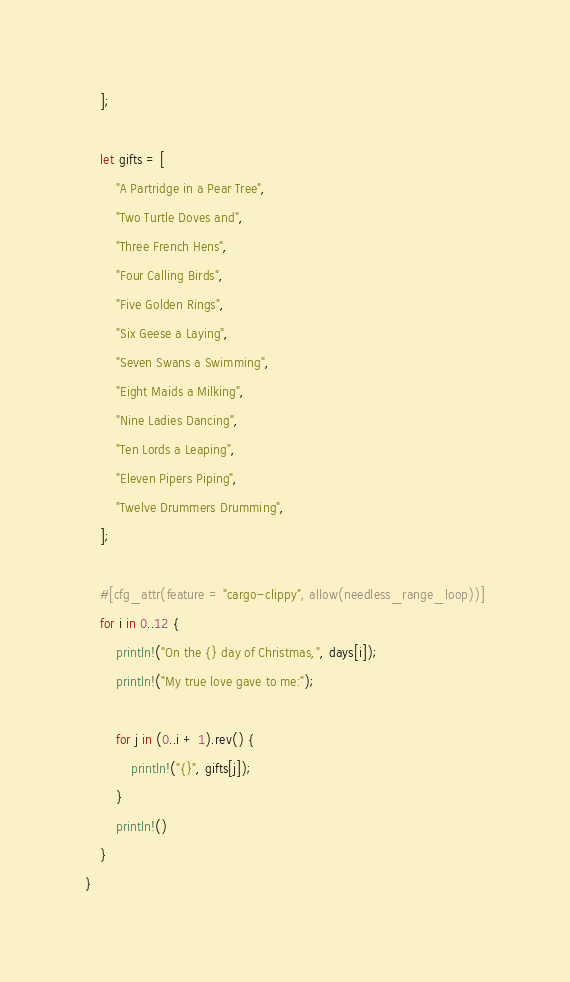Convert code to text. <code><loc_0><loc_0><loc_500><loc_500><_Rust_>    ];

    let gifts = [
        "A Partridge in a Pear Tree",
        "Two Turtle Doves and",
        "Three French Hens",
        "Four Calling Birds",
        "Five Golden Rings",
        "Six Geese a Laying",
        "Seven Swans a Swimming",
        "Eight Maids a Milking",
        "Nine Ladies Dancing",
        "Ten Lords a Leaping",
        "Eleven Pipers Piping",
        "Twelve Drummers Drumming",
    ];

    #[cfg_attr(feature = "cargo-clippy", allow(needless_range_loop))]
    for i in 0..12 {
        println!("On the {} day of Christmas,", days[i]);
        println!("My true love gave to me:");

        for j in (0..i + 1).rev() {
            println!("{}", gifts[j]);
        }
        println!()
    }
}
</code> 